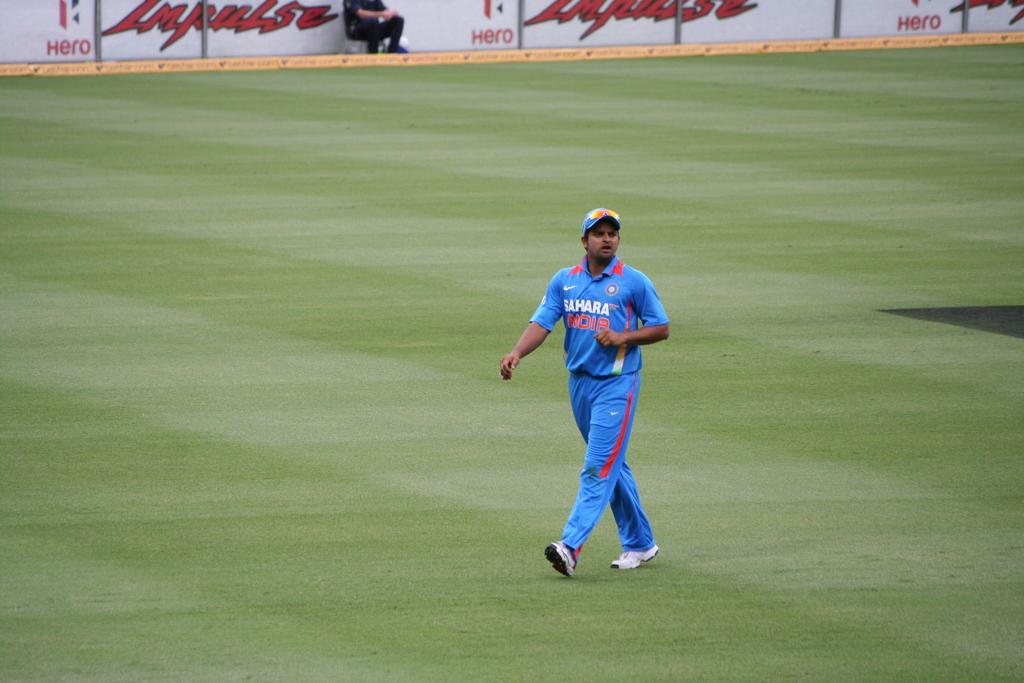What country is mentioned on the jersey?
Your answer should be very brief. India. What is written on the left side of the back sign?
Your answer should be very brief. Hero. 